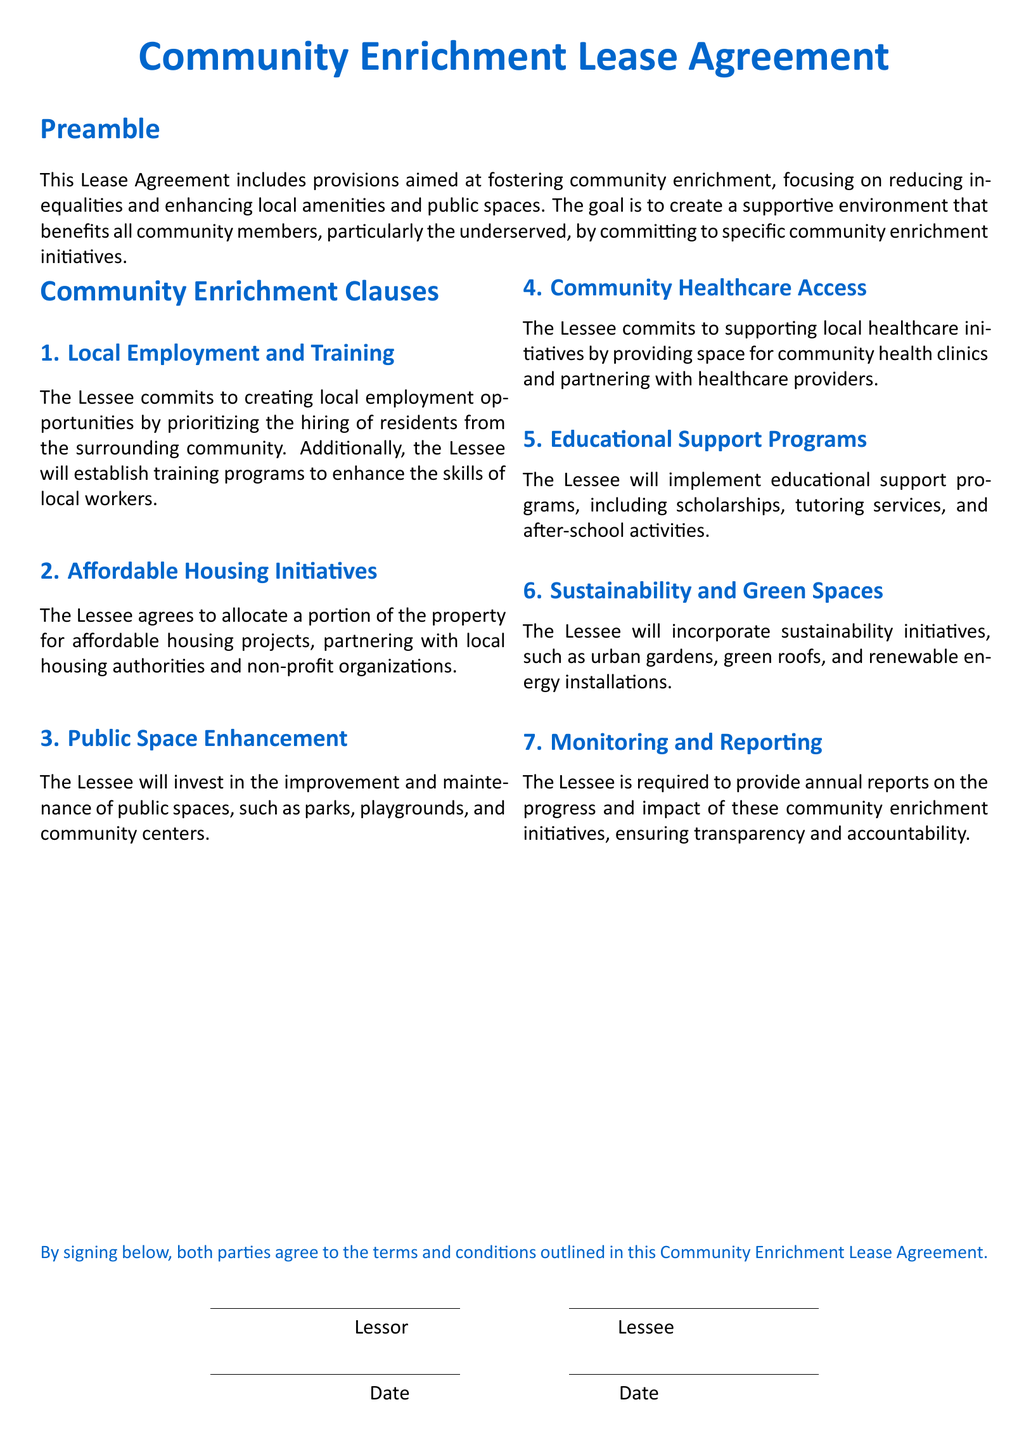What commitment is made regarding local employment? The Lessee commits to creating local employment opportunities by prioritizing the hiring of residents from the surrounding community.
Answer: Local employment opportunities What is one initiative related to housing? The Lessee agrees to allocate a portion of the property for affordable housing projects, partnering with local housing authorities and non-profit organizations.
Answer: Affordable housing projects How will public spaces be addressed? The Lessee will invest in the improvement and maintenance of public spaces, such as parks, playgrounds, and community centers.
Answer: Improvement and maintenance of public spaces What type of healthcare support is included? The Lessee commits to supporting local healthcare initiatives by providing space for community health clinics and partnering with healthcare providers.
Answer: Community health clinics What educational initiatives will be implemented? The Lessee will implement educational support programs, including scholarships, tutoring services, and after-school activities.
Answer: Educational support programs How frequently does the Lessee report on community initiatives? The Lessee is required to provide annual reports on the progress and impact of these community enrichment initiatives, ensuring transparency and accountability.
Answer: Annual reports What is the purpose of the Community Enrichment Lease Agreement? The goal is to create a supportive environment that benefits all community members, particularly the underserved, by committing to specific community enrichment initiatives.
Answer: Supportive environment How does the Lessee promote sustainability? The Lessee will incorporate sustainability initiatives, such as urban gardens, green roofs, and renewable energy installations.
Answer: Sustainability initiatives 